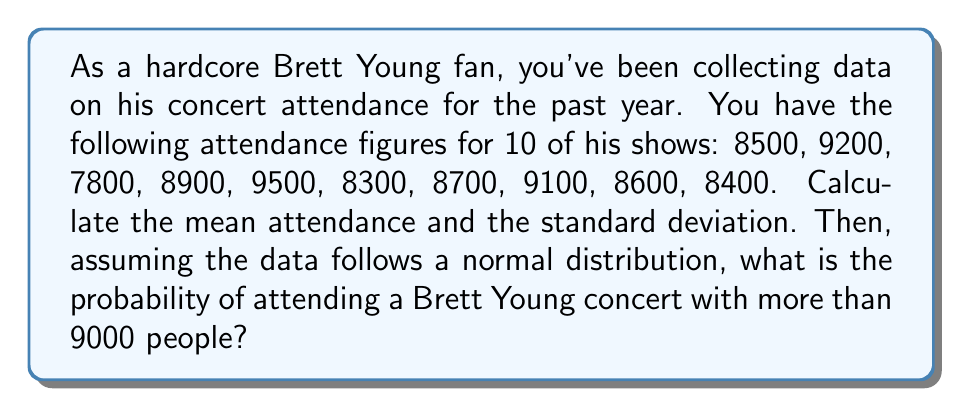What is the answer to this math problem? Let's approach this step-by-step:

1. Calculate the mean attendance:
   $$ \bar{x} = \frac{\sum_{i=1}^{n} x_i}{n} $$
   $$ \bar{x} = \frac{8500 + 9200 + 7800 + 8900 + 9500 + 8300 + 8700 + 9100 + 8600 + 8400}{10} = 8700 $$

2. Calculate the standard deviation:
   $$ s = \sqrt{\frac{\sum_{i=1}^{n} (x_i - \bar{x})^2}{n-1}} $$
   
   First, let's calculate $(x_i - \bar{x})^2$ for each value:
   $$ (8500 - 8700)^2 = 40000, (9200 - 8700)^2 = 250000, ... $$
   
   Sum these values:
   $$ \sum_{i=1}^{n} (x_i - \bar{x})^2 = 2,090,000 $$
   
   Now, we can calculate the standard deviation:
   $$ s = \sqrt{\frac{2,090,000}{9}} \approx 482.18 $$

3. To find the probability of attending a concert with more than 9000 people, we need to calculate the z-score for 9000:
   $$ z = \frac{x - \bar{x}}{s} = \frac{9000 - 8700}{482.18} \approx 0.62 $$

4. Using a standard normal distribution table or calculator, we can find the area to the right of z = 0.62:
   $$ P(Z > 0.62) \approx 0.2676 $$

Therefore, the probability of attending a Brett Young concert with more than 9000 people is approximately 0.2676 or 26.76%.
Answer: Mean attendance: 8700
Standard deviation: 482.18
Probability of attending a concert with more than 9000 people: 0.2676 or 26.76% 